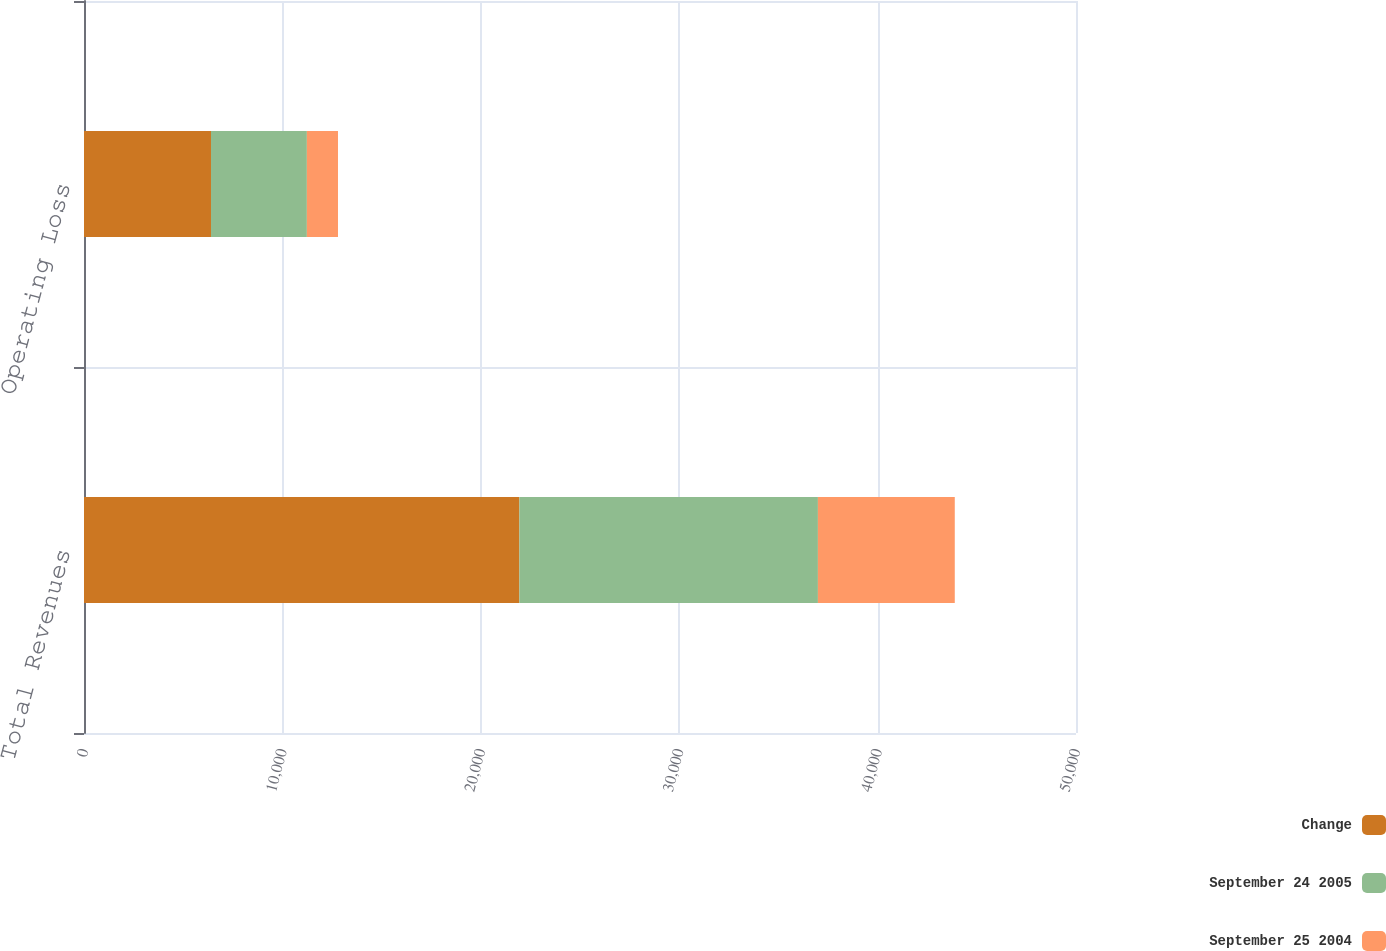Convert chart. <chart><loc_0><loc_0><loc_500><loc_500><stacked_bar_chart><ecel><fcel>Total Revenues<fcel>Operating Loss<nl><fcel>Change<fcel>21945<fcel>6401<nl><fcel>September 24 2005<fcel>15047<fcel>4833<nl><fcel>September 25 2004<fcel>6898<fcel>1568<nl></chart> 